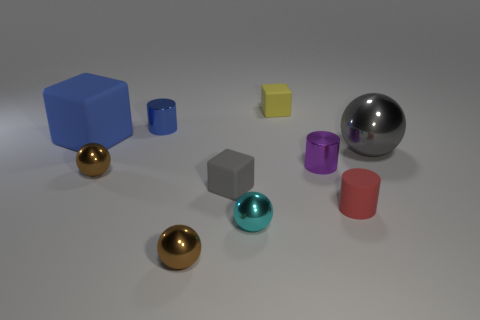Subtract all small metallic spheres. How many spheres are left? 1 Subtract all brown spheres. How many spheres are left? 2 Subtract all spheres. How many objects are left? 6 Subtract 0 green cylinders. How many objects are left? 10 Subtract 3 cylinders. How many cylinders are left? 0 Subtract all brown blocks. Subtract all gray cylinders. How many blocks are left? 3 Subtract all yellow balls. How many gray cubes are left? 1 Subtract all small yellow shiny balls. Subtract all tiny red rubber cylinders. How many objects are left? 9 Add 7 tiny purple objects. How many tiny purple objects are left? 8 Add 7 tiny blue things. How many tiny blue things exist? 8 